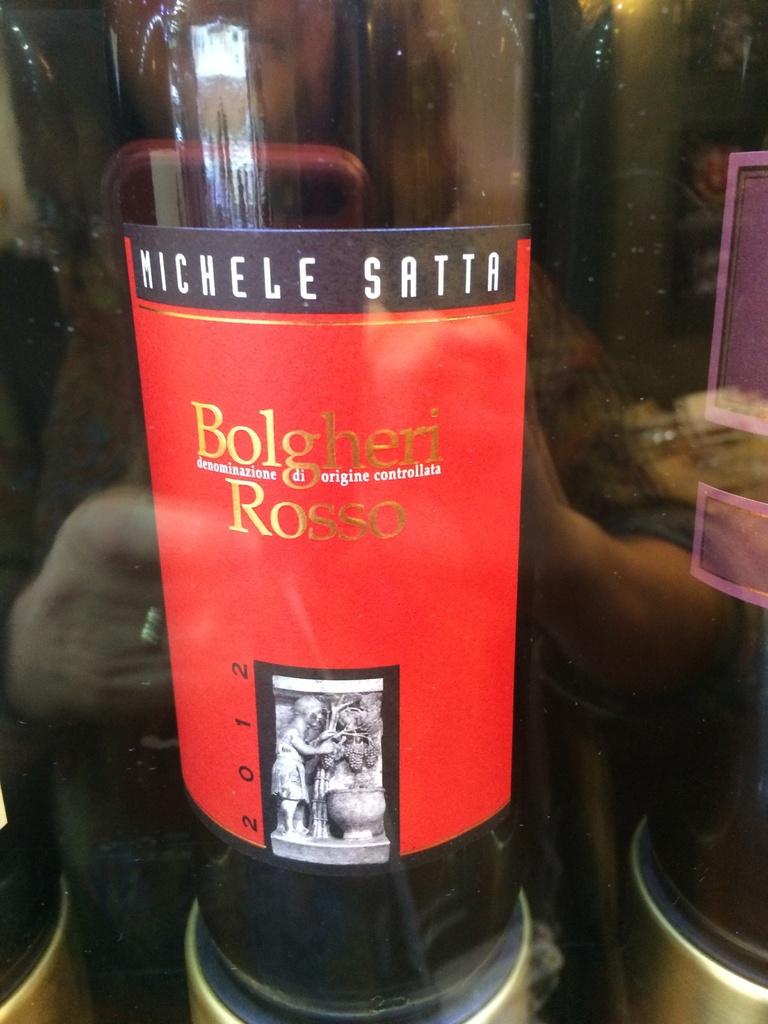In which year was this wine bottled?
Keep it short and to the point. 2012. What type of wine is this?
Provide a succinct answer. Bolgheri rosso. 